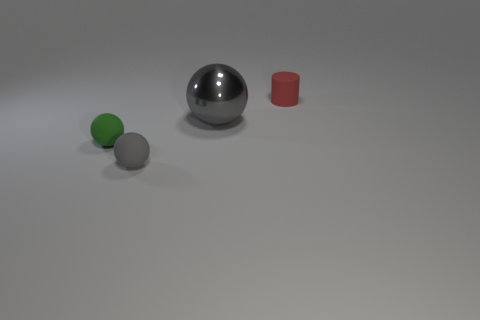Subtract all gray spheres. How many were subtracted if there are1gray spheres left? 1 Add 1 tiny cyan objects. How many objects exist? 5 Subtract all cylinders. How many objects are left? 3 Subtract 0 cyan cubes. How many objects are left? 4 Subtract all balls. Subtract all metal balls. How many objects are left? 0 Add 4 large gray metallic things. How many large gray metallic things are left? 5 Add 1 gray balls. How many gray balls exist? 3 